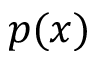<formula> <loc_0><loc_0><loc_500><loc_500>p ( x )</formula> 